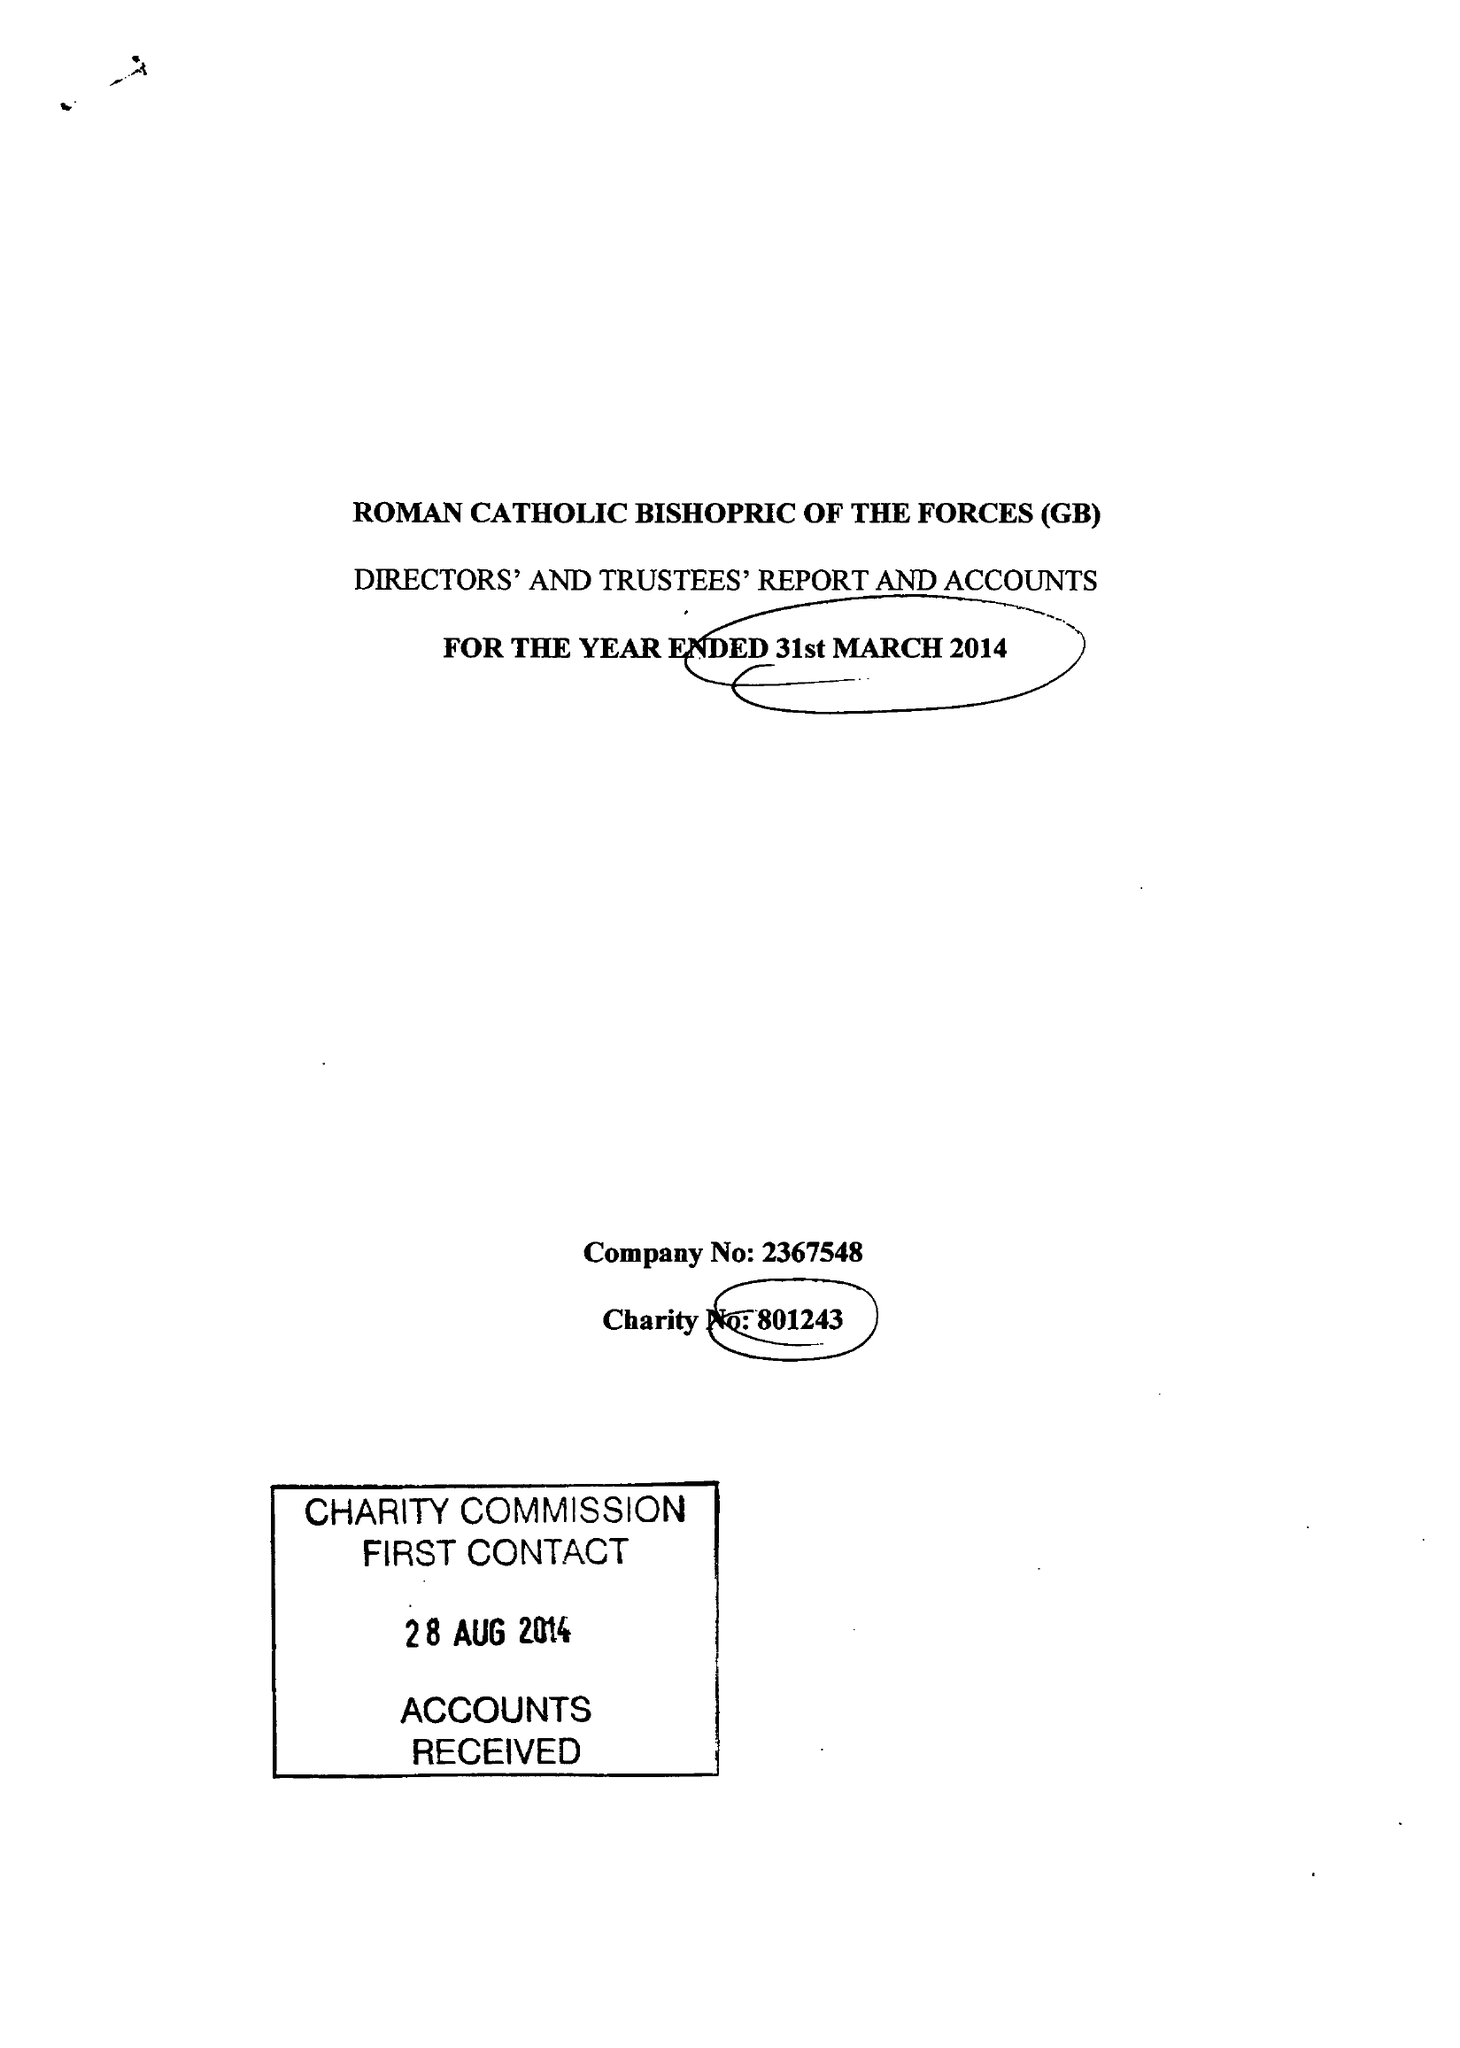What is the value for the address__street_line?
Answer the question using a single word or phrase. THORNHILL ROAD 